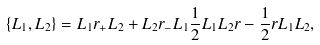<formula> <loc_0><loc_0><loc_500><loc_500>\{ L _ { 1 } , L _ { 2 } \} = L _ { 1 } r _ { + } L _ { 2 } + L _ { 2 } r _ { - } L _ { 1 } \frac { 1 } { 2 } L _ { 1 } L _ { 2 } r - \frac { 1 } { 2 } r L _ { 1 } L _ { 2 } ,</formula> 